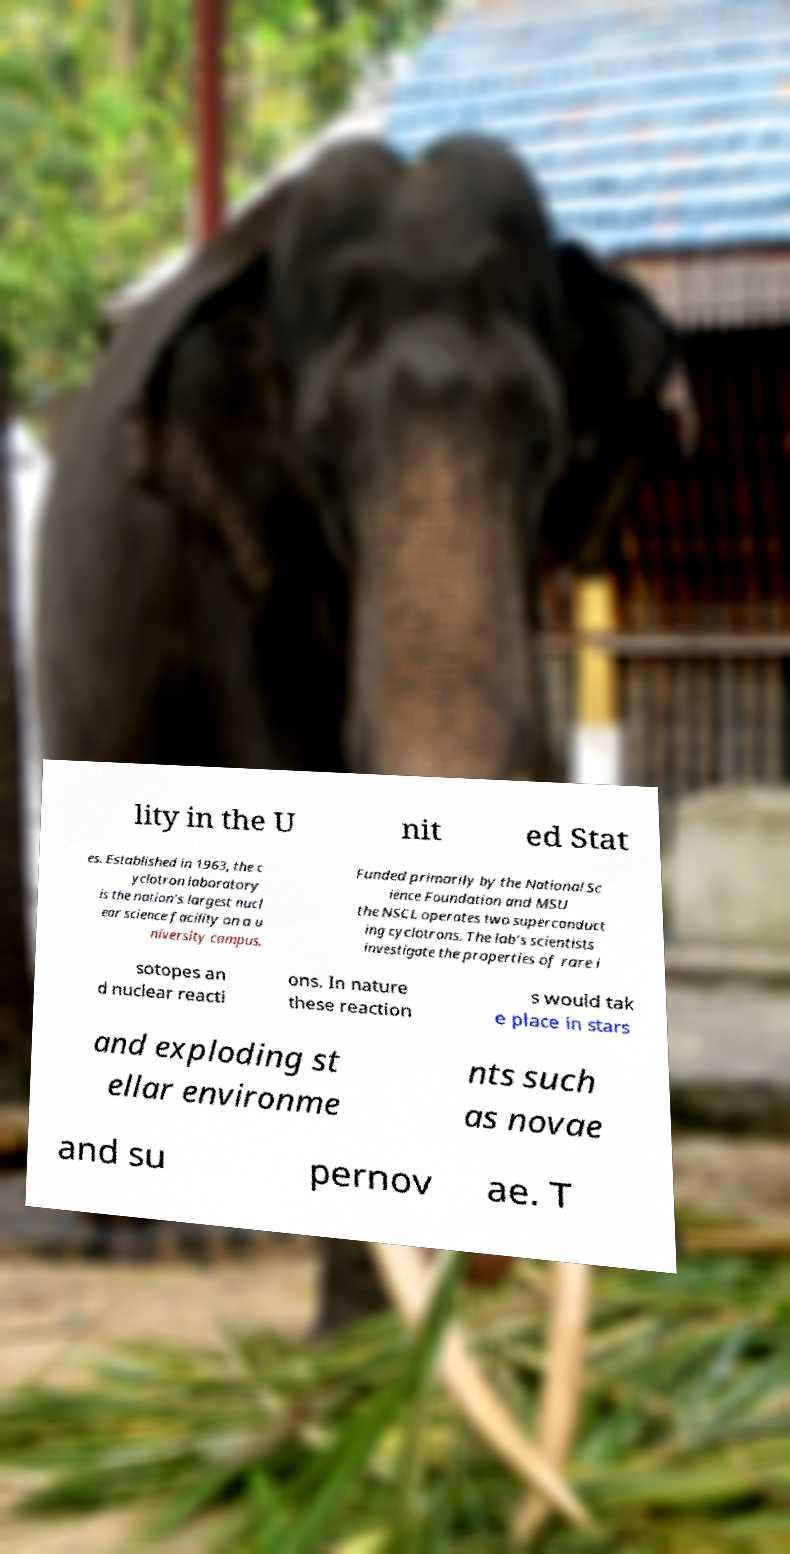I need the written content from this picture converted into text. Can you do that? lity in the U nit ed Stat es. Established in 1963, the c yclotron laboratory is the nation’s largest nucl ear science facility on a u niversity campus. Funded primarily by the National Sc ience Foundation and MSU the NSCL operates two superconduct ing cyclotrons. The lab’s scientists investigate the properties of rare i sotopes an d nuclear reacti ons. In nature these reaction s would tak e place in stars and exploding st ellar environme nts such as novae and su pernov ae. T 